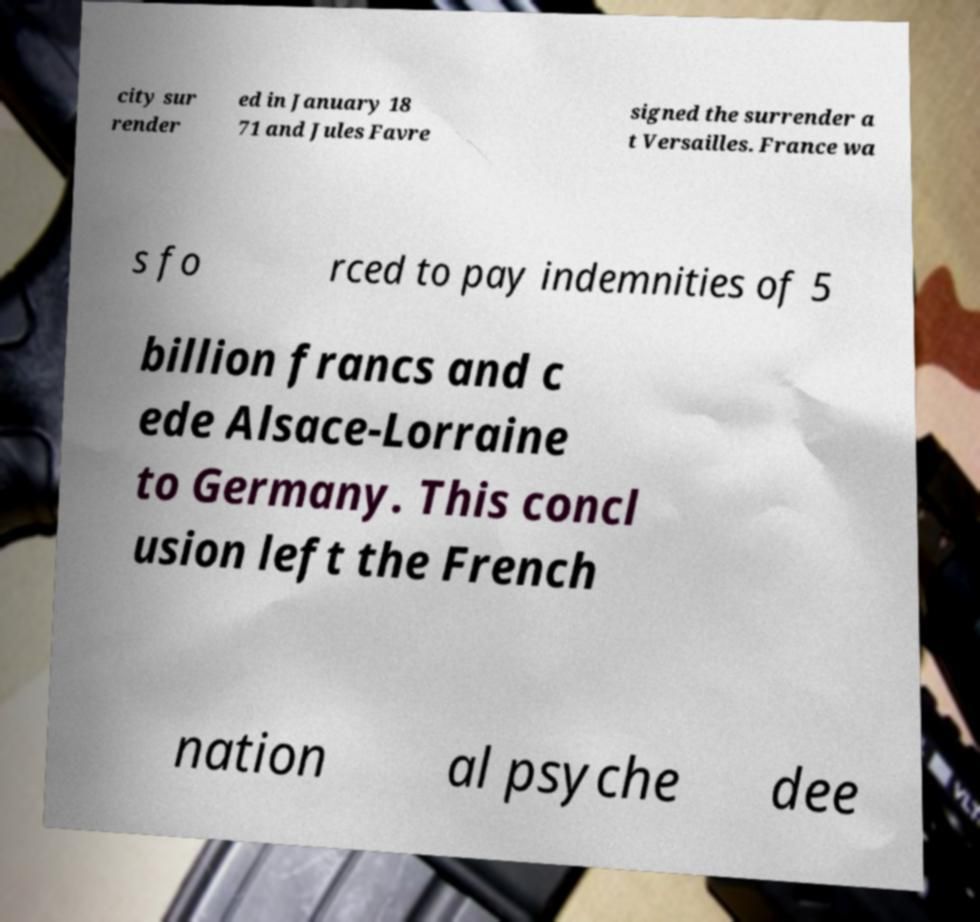For documentation purposes, I need the text within this image transcribed. Could you provide that? city sur render ed in January 18 71 and Jules Favre signed the surrender a t Versailles. France wa s fo rced to pay indemnities of 5 billion francs and c ede Alsace-Lorraine to Germany. This concl usion left the French nation al psyche dee 